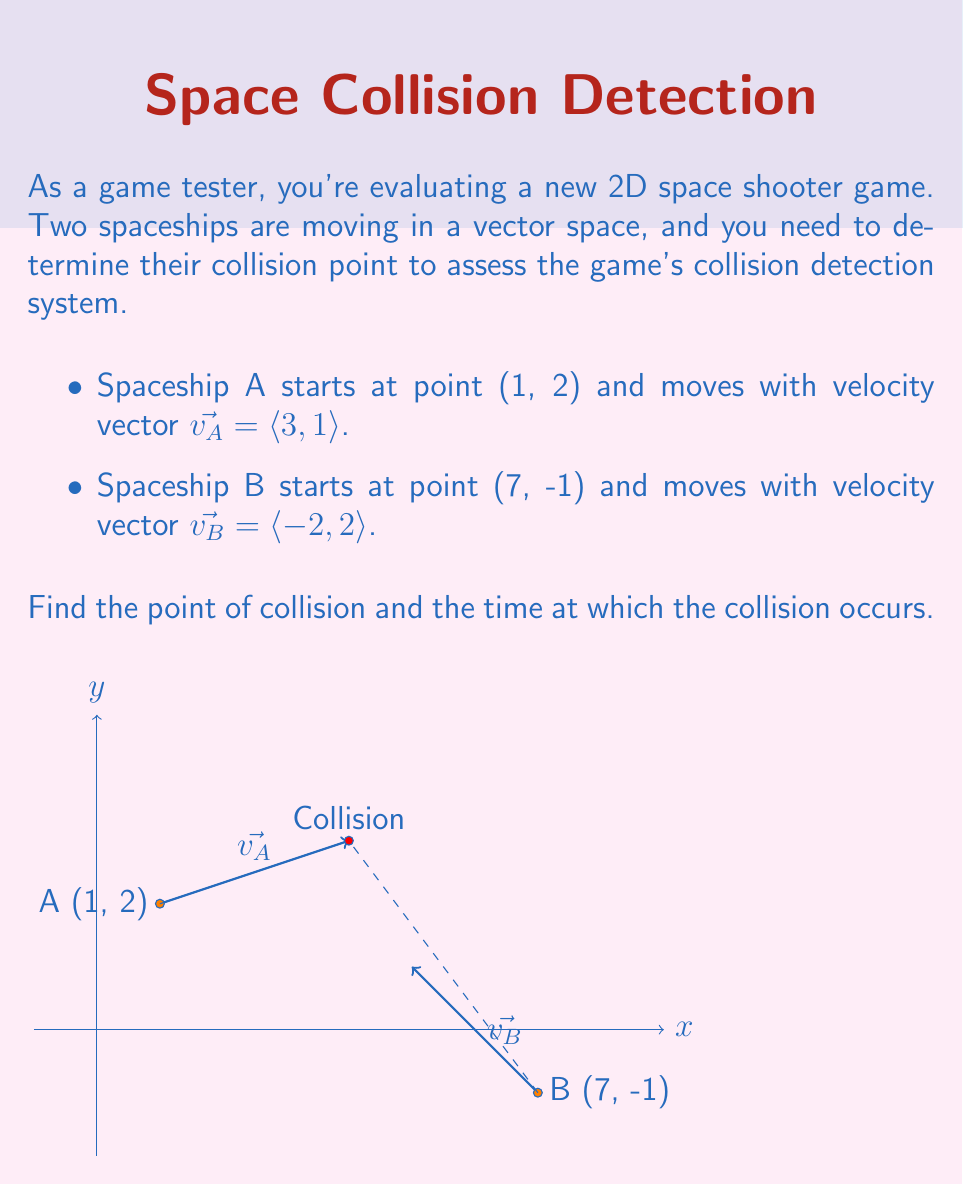Provide a solution to this math problem. Let's approach this step-by-step:

1) We can represent the position of each spaceship as a function of time:

   Spaceship A: $\vec{r_A}(t) = \langle 1, 2 \rangle + t\langle 3, 1 \rangle = \langle 1+3t, 2+t \rangle$
   Spaceship B: $\vec{r_B}(t) = \langle 7, -1 \rangle + t\langle -2, 2 \rangle = \langle 7-2t, -1+2t \rangle$

2) At the point of collision, these positions will be equal:

   $\vec{r_A}(t) = \vec{r_B}(t)$

3) This gives us a system of equations:

   $1+3t = 7-2t$
   $2+t = -1+2t$

4) From the second equation:
   
   $2+t = -1+2t$
   $3 = t$

5) Substituting this into the first equation:

   $1+3(3) = 7-2(3)$
   $10 = 1$

   This checks out.

6) So, the collision occurs at $t=3$.

7) To find the point of collision, we can substitute $t=3$ into either position function:

   $\vec{r_A}(3) = \langle 1+3(3), 2+(3) \rangle = \langle 10, 5 \rangle$

   Or:

   $\vec{r_B}(3) = \langle 7-2(3), -1+2(3) \rangle = \langle 1, 5 \rangle$

Therefore, the spaceships collide at the point (10, 5) after 3 time units.
Answer: Point of collision: (10, 5); Time of collision: 3 units 